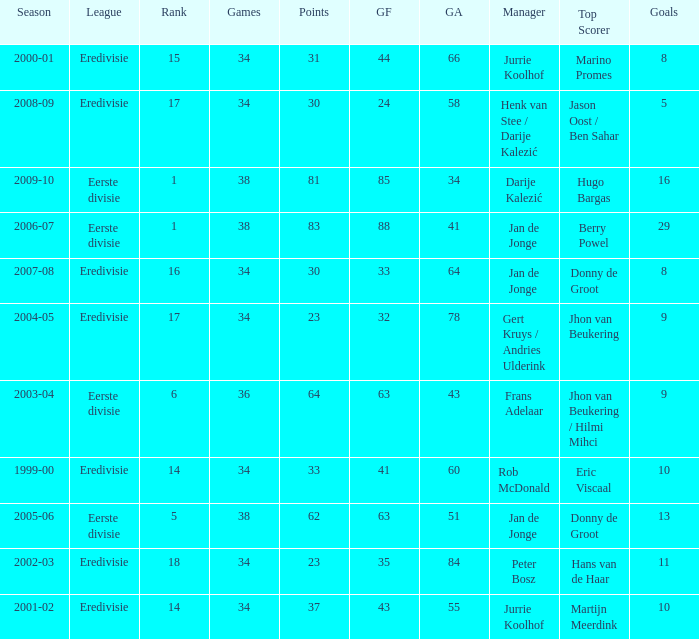Who is the manager whose rank is 16? Jan de Jonge. 